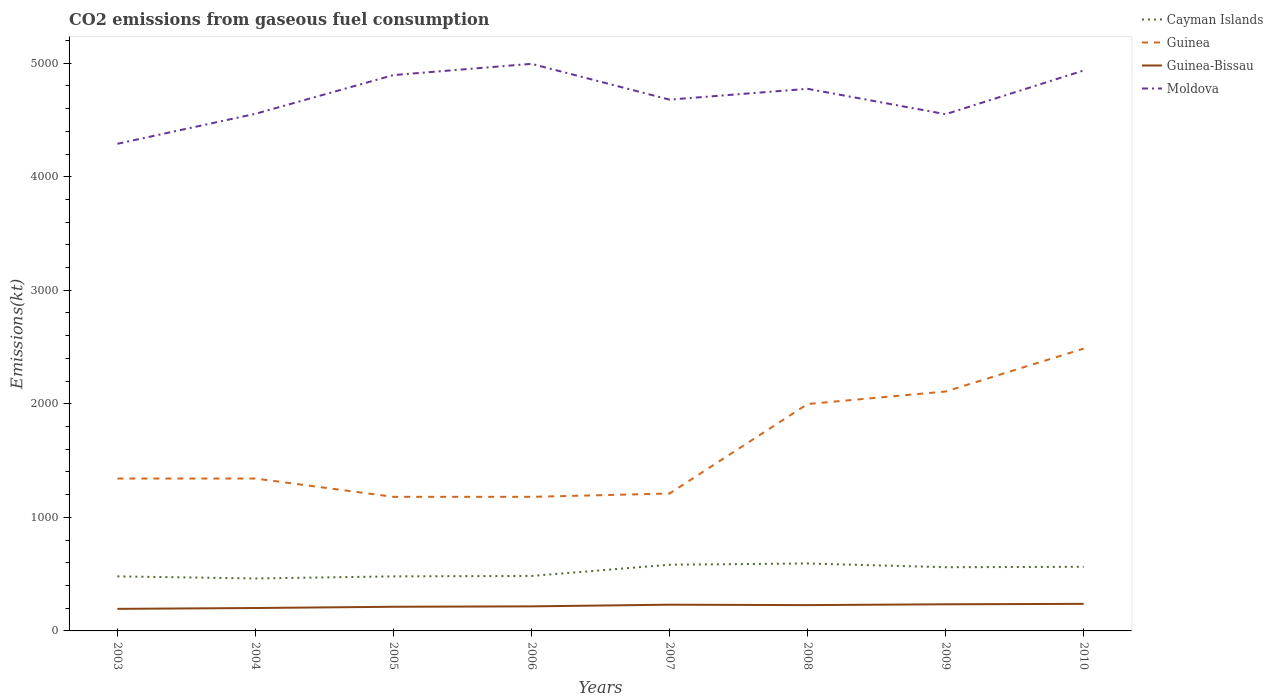How many different coloured lines are there?
Ensure brevity in your answer.  4. Is the number of lines equal to the number of legend labels?
Make the answer very short. Yes. Across all years, what is the maximum amount of CO2 emitted in Guinea-Bissau?
Offer a terse response. 194.35. In which year was the amount of CO2 emitted in Cayman Islands maximum?
Keep it short and to the point. 2004. What is the total amount of CO2 emitted in Moldova in the graph?
Offer a terse response. -484.04. What is the difference between the highest and the second highest amount of CO2 emitted in Guinea?
Your answer should be compact. 1305.45. What is the difference between the highest and the lowest amount of CO2 emitted in Cayman Islands?
Offer a terse response. 4. Is the amount of CO2 emitted in Guinea-Bissau strictly greater than the amount of CO2 emitted in Guinea over the years?
Your response must be concise. Yes. How many lines are there?
Offer a terse response. 4. What is the difference between two consecutive major ticks on the Y-axis?
Keep it short and to the point. 1000. Where does the legend appear in the graph?
Provide a short and direct response. Top right. What is the title of the graph?
Your response must be concise. CO2 emissions from gaseous fuel consumption. What is the label or title of the X-axis?
Your response must be concise. Years. What is the label or title of the Y-axis?
Your answer should be compact. Emissions(kt). What is the Emissions(kt) of Cayman Islands in 2003?
Your answer should be compact. 480.38. What is the Emissions(kt) in Guinea in 2003?
Keep it short and to the point. 1342.12. What is the Emissions(kt) in Guinea-Bissau in 2003?
Make the answer very short. 194.35. What is the Emissions(kt) of Moldova in 2003?
Your response must be concise. 4290.39. What is the Emissions(kt) of Cayman Islands in 2004?
Make the answer very short. 462.04. What is the Emissions(kt) of Guinea in 2004?
Offer a very short reply. 1342.12. What is the Emissions(kt) in Guinea-Bissau in 2004?
Make the answer very short. 201.69. What is the Emissions(kt) in Moldova in 2004?
Offer a terse response. 4554.41. What is the Emissions(kt) of Cayman Islands in 2005?
Make the answer very short. 480.38. What is the Emissions(kt) in Guinea in 2005?
Your answer should be compact. 1180.77. What is the Emissions(kt) of Guinea-Bissau in 2005?
Provide a succinct answer. 212.69. What is the Emissions(kt) in Moldova in 2005?
Provide a short and direct response. 4895.44. What is the Emissions(kt) in Cayman Islands in 2006?
Ensure brevity in your answer.  484.04. What is the Emissions(kt) in Guinea in 2006?
Your response must be concise. 1180.77. What is the Emissions(kt) of Guinea-Bissau in 2006?
Give a very brief answer. 216.35. What is the Emissions(kt) in Moldova in 2006?
Offer a terse response. 4994.45. What is the Emissions(kt) of Cayman Islands in 2007?
Offer a terse response. 583.05. What is the Emissions(kt) of Guinea in 2007?
Your answer should be compact. 1210.11. What is the Emissions(kt) of Guinea-Bissau in 2007?
Keep it short and to the point. 231.02. What is the Emissions(kt) of Moldova in 2007?
Give a very brief answer. 4679.09. What is the Emissions(kt) in Cayman Islands in 2008?
Keep it short and to the point. 594.05. What is the Emissions(kt) of Guinea in 2008?
Offer a terse response. 1998.52. What is the Emissions(kt) of Guinea-Bissau in 2008?
Your response must be concise. 227.35. What is the Emissions(kt) in Moldova in 2008?
Provide a succinct answer. 4774.43. What is the Emissions(kt) of Cayman Islands in 2009?
Provide a succinct answer. 561.05. What is the Emissions(kt) in Guinea in 2009?
Your response must be concise. 2108.53. What is the Emissions(kt) in Guinea-Bissau in 2009?
Keep it short and to the point. 234.69. What is the Emissions(kt) of Moldova in 2009?
Your response must be concise. 4550.75. What is the Emissions(kt) in Cayman Islands in 2010?
Give a very brief answer. 564.72. What is the Emissions(kt) of Guinea in 2010?
Provide a succinct answer. 2486.23. What is the Emissions(kt) in Guinea-Bissau in 2010?
Ensure brevity in your answer.  238.35. What is the Emissions(kt) in Moldova in 2010?
Ensure brevity in your answer.  4935.78. Across all years, what is the maximum Emissions(kt) of Cayman Islands?
Provide a succinct answer. 594.05. Across all years, what is the maximum Emissions(kt) in Guinea?
Provide a short and direct response. 2486.23. Across all years, what is the maximum Emissions(kt) of Guinea-Bissau?
Give a very brief answer. 238.35. Across all years, what is the maximum Emissions(kt) in Moldova?
Provide a succinct answer. 4994.45. Across all years, what is the minimum Emissions(kt) in Cayman Islands?
Keep it short and to the point. 462.04. Across all years, what is the minimum Emissions(kt) in Guinea?
Your answer should be very brief. 1180.77. Across all years, what is the minimum Emissions(kt) in Guinea-Bissau?
Your answer should be very brief. 194.35. Across all years, what is the minimum Emissions(kt) in Moldova?
Your response must be concise. 4290.39. What is the total Emissions(kt) in Cayman Islands in the graph?
Provide a succinct answer. 4209.72. What is the total Emissions(kt) in Guinea in the graph?
Offer a terse response. 1.28e+04. What is the total Emissions(kt) in Guinea-Bissau in the graph?
Offer a terse response. 1756.49. What is the total Emissions(kt) in Moldova in the graph?
Your answer should be very brief. 3.77e+04. What is the difference between the Emissions(kt) in Cayman Islands in 2003 and that in 2004?
Ensure brevity in your answer.  18.34. What is the difference between the Emissions(kt) of Guinea in 2003 and that in 2004?
Your response must be concise. 0. What is the difference between the Emissions(kt) of Guinea-Bissau in 2003 and that in 2004?
Keep it short and to the point. -7.33. What is the difference between the Emissions(kt) in Moldova in 2003 and that in 2004?
Your answer should be very brief. -264.02. What is the difference between the Emissions(kt) of Cayman Islands in 2003 and that in 2005?
Offer a terse response. 0. What is the difference between the Emissions(kt) of Guinea in 2003 and that in 2005?
Your response must be concise. 161.35. What is the difference between the Emissions(kt) in Guinea-Bissau in 2003 and that in 2005?
Provide a short and direct response. -18.34. What is the difference between the Emissions(kt) in Moldova in 2003 and that in 2005?
Make the answer very short. -605.05. What is the difference between the Emissions(kt) in Cayman Islands in 2003 and that in 2006?
Offer a terse response. -3.67. What is the difference between the Emissions(kt) of Guinea in 2003 and that in 2006?
Your answer should be compact. 161.35. What is the difference between the Emissions(kt) of Guinea-Bissau in 2003 and that in 2006?
Provide a succinct answer. -22. What is the difference between the Emissions(kt) in Moldova in 2003 and that in 2006?
Make the answer very short. -704.06. What is the difference between the Emissions(kt) of Cayman Islands in 2003 and that in 2007?
Offer a terse response. -102.68. What is the difference between the Emissions(kt) in Guinea in 2003 and that in 2007?
Provide a succinct answer. 132.01. What is the difference between the Emissions(kt) in Guinea-Bissau in 2003 and that in 2007?
Offer a very short reply. -36.67. What is the difference between the Emissions(kt) in Moldova in 2003 and that in 2007?
Provide a short and direct response. -388.7. What is the difference between the Emissions(kt) in Cayman Islands in 2003 and that in 2008?
Offer a terse response. -113.68. What is the difference between the Emissions(kt) in Guinea in 2003 and that in 2008?
Offer a very short reply. -656.39. What is the difference between the Emissions(kt) of Guinea-Bissau in 2003 and that in 2008?
Keep it short and to the point. -33. What is the difference between the Emissions(kt) of Moldova in 2003 and that in 2008?
Your response must be concise. -484.04. What is the difference between the Emissions(kt) of Cayman Islands in 2003 and that in 2009?
Offer a terse response. -80.67. What is the difference between the Emissions(kt) in Guinea in 2003 and that in 2009?
Offer a very short reply. -766.4. What is the difference between the Emissions(kt) in Guinea-Bissau in 2003 and that in 2009?
Provide a short and direct response. -40.34. What is the difference between the Emissions(kt) of Moldova in 2003 and that in 2009?
Your answer should be compact. -260.36. What is the difference between the Emissions(kt) of Cayman Islands in 2003 and that in 2010?
Your answer should be very brief. -84.34. What is the difference between the Emissions(kt) of Guinea in 2003 and that in 2010?
Your answer should be very brief. -1144.1. What is the difference between the Emissions(kt) in Guinea-Bissau in 2003 and that in 2010?
Offer a terse response. -44. What is the difference between the Emissions(kt) of Moldova in 2003 and that in 2010?
Provide a succinct answer. -645.39. What is the difference between the Emissions(kt) of Cayman Islands in 2004 and that in 2005?
Give a very brief answer. -18.34. What is the difference between the Emissions(kt) of Guinea in 2004 and that in 2005?
Make the answer very short. 161.35. What is the difference between the Emissions(kt) of Guinea-Bissau in 2004 and that in 2005?
Ensure brevity in your answer.  -11. What is the difference between the Emissions(kt) in Moldova in 2004 and that in 2005?
Provide a short and direct response. -341.03. What is the difference between the Emissions(kt) of Cayman Islands in 2004 and that in 2006?
Provide a short and direct response. -22. What is the difference between the Emissions(kt) of Guinea in 2004 and that in 2006?
Offer a very short reply. 161.35. What is the difference between the Emissions(kt) of Guinea-Bissau in 2004 and that in 2006?
Your answer should be very brief. -14.67. What is the difference between the Emissions(kt) in Moldova in 2004 and that in 2006?
Give a very brief answer. -440.04. What is the difference between the Emissions(kt) of Cayman Islands in 2004 and that in 2007?
Your response must be concise. -121.01. What is the difference between the Emissions(kt) of Guinea in 2004 and that in 2007?
Give a very brief answer. 132.01. What is the difference between the Emissions(kt) of Guinea-Bissau in 2004 and that in 2007?
Provide a succinct answer. -29.34. What is the difference between the Emissions(kt) in Moldova in 2004 and that in 2007?
Your answer should be very brief. -124.68. What is the difference between the Emissions(kt) of Cayman Islands in 2004 and that in 2008?
Provide a succinct answer. -132.01. What is the difference between the Emissions(kt) of Guinea in 2004 and that in 2008?
Make the answer very short. -656.39. What is the difference between the Emissions(kt) of Guinea-Bissau in 2004 and that in 2008?
Your answer should be very brief. -25.67. What is the difference between the Emissions(kt) of Moldova in 2004 and that in 2008?
Provide a succinct answer. -220.02. What is the difference between the Emissions(kt) of Cayman Islands in 2004 and that in 2009?
Provide a succinct answer. -99.01. What is the difference between the Emissions(kt) of Guinea in 2004 and that in 2009?
Keep it short and to the point. -766.4. What is the difference between the Emissions(kt) of Guinea-Bissau in 2004 and that in 2009?
Provide a succinct answer. -33. What is the difference between the Emissions(kt) of Moldova in 2004 and that in 2009?
Make the answer very short. 3.67. What is the difference between the Emissions(kt) of Cayman Islands in 2004 and that in 2010?
Provide a succinct answer. -102.68. What is the difference between the Emissions(kt) of Guinea in 2004 and that in 2010?
Provide a succinct answer. -1144.1. What is the difference between the Emissions(kt) in Guinea-Bissau in 2004 and that in 2010?
Offer a very short reply. -36.67. What is the difference between the Emissions(kt) in Moldova in 2004 and that in 2010?
Your answer should be very brief. -381.37. What is the difference between the Emissions(kt) in Cayman Islands in 2005 and that in 2006?
Offer a terse response. -3.67. What is the difference between the Emissions(kt) of Guinea in 2005 and that in 2006?
Offer a very short reply. 0. What is the difference between the Emissions(kt) of Guinea-Bissau in 2005 and that in 2006?
Keep it short and to the point. -3.67. What is the difference between the Emissions(kt) in Moldova in 2005 and that in 2006?
Your response must be concise. -99.01. What is the difference between the Emissions(kt) in Cayman Islands in 2005 and that in 2007?
Keep it short and to the point. -102.68. What is the difference between the Emissions(kt) of Guinea in 2005 and that in 2007?
Ensure brevity in your answer.  -29.34. What is the difference between the Emissions(kt) of Guinea-Bissau in 2005 and that in 2007?
Ensure brevity in your answer.  -18.34. What is the difference between the Emissions(kt) of Moldova in 2005 and that in 2007?
Offer a very short reply. 216.35. What is the difference between the Emissions(kt) in Cayman Islands in 2005 and that in 2008?
Offer a very short reply. -113.68. What is the difference between the Emissions(kt) of Guinea in 2005 and that in 2008?
Make the answer very short. -817.74. What is the difference between the Emissions(kt) of Guinea-Bissau in 2005 and that in 2008?
Your response must be concise. -14.67. What is the difference between the Emissions(kt) in Moldova in 2005 and that in 2008?
Provide a succinct answer. 121.01. What is the difference between the Emissions(kt) of Cayman Islands in 2005 and that in 2009?
Make the answer very short. -80.67. What is the difference between the Emissions(kt) of Guinea in 2005 and that in 2009?
Make the answer very short. -927.75. What is the difference between the Emissions(kt) in Guinea-Bissau in 2005 and that in 2009?
Ensure brevity in your answer.  -22. What is the difference between the Emissions(kt) of Moldova in 2005 and that in 2009?
Your answer should be very brief. 344.7. What is the difference between the Emissions(kt) in Cayman Islands in 2005 and that in 2010?
Your answer should be very brief. -84.34. What is the difference between the Emissions(kt) of Guinea in 2005 and that in 2010?
Offer a very short reply. -1305.45. What is the difference between the Emissions(kt) in Guinea-Bissau in 2005 and that in 2010?
Your response must be concise. -25.67. What is the difference between the Emissions(kt) in Moldova in 2005 and that in 2010?
Your answer should be compact. -40.34. What is the difference between the Emissions(kt) of Cayman Islands in 2006 and that in 2007?
Make the answer very short. -99.01. What is the difference between the Emissions(kt) of Guinea in 2006 and that in 2007?
Your answer should be compact. -29.34. What is the difference between the Emissions(kt) in Guinea-Bissau in 2006 and that in 2007?
Give a very brief answer. -14.67. What is the difference between the Emissions(kt) of Moldova in 2006 and that in 2007?
Offer a terse response. 315.36. What is the difference between the Emissions(kt) of Cayman Islands in 2006 and that in 2008?
Ensure brevity in your answer.  -110.01. What is the difference between the Emissions(kt) in Guinea in 2006 and that in 2008?
Your answer should be very brief. -817.74. What is the difference between the Emissions(kt) in Guinea-Bissau in 2006 and that in 2008?
Provide a succinct answer. -11. What is the difference between the Emissions(kt) of Moldova in 2006 and that in 2008?
Make the answer very short. 220.02. What is the difference between the Emissions(kt) in Cayman Islands in 2006 and that in 2009?
Your answer should be very brief. -77.01. What is the difference between the Emissions(kt) in Guinea in 2006 and that in 2009?
Give a very brief answer. -927.75. What is the difference between the Emissions(kt) of Guinea-Bissau in 2006 and that in 2009?
Make the answer very short. -18.34. What is the difference between the Emissions(kt) in Moldova in 2006 and that in 2009?
Make the answer very short. 443.71. What is the difference between the Emissions(kt) in Cayman Islands in 2006 and that in 2010?
Ensure brevity in your answer.  -80.67. What is the difference between the Emissions(kt) of Guinea in 2006 and that in 2010?
Offer a very short reply. -1305.45. What is the difference between the Emissions(kt) of Guinea-Bissau in 2006 and that in 2010?
Provide a succinct answer. -22. What is the difference between the Emissions(kt) in Moldova in 2006 and that in 2010?
Offer a terse response. 58.67. What is the difference between the Emissions(kt) of Cayman Islands in 2007 and that in 2008?
Keep it short and to the point. -11. What is the difference between the Emissions(kt) of Guinea in 2007 and that in 2008?
Offer a very short reply. -788.4. What is the difference between the Emissions(kt) of Guinea-Bissau in 2007 and that in 2008?
Your answer should be very brief. 3.67. What is the difference between the Emissions(kt) in Moldova in 2007 and that in 2008?
Your response must be concise. -95.34. What is the difference between the Emissions(kt) of Cayman Islands in 2007 and that in 2009?
Ensure brevity in your answer.  22. What is the difference between the Emissions(kt) of Guinea in 2007 and that in 2009?
Your answer should be compact. -898.41. What is the difference between the Emissions(kt) of Guinea-Bissau in 2007 and that in 2009?
Ensure brevity in your answer.  -3.67. What is the difference between the Emissions(kt) of Moldova in 2007 and that in 2009?
Offer a very short reply. 128.34. What is the difference between the Emissions(kt) in Cayman Islands in 2007 and that in 2010?
Ensure brevity in your answer.  18.34. What is the difference between the Emissions(kt) in Guinea in 2007 and that in 2010?
Your answer should be compact. -1276.12. What is the difference between the Emissions(kt) of Guinea-Bissau in 2007 and that in 2010?
Ensure brevity in your answer.  -7.33. What is the difference between the Emissions(kt) in Moldova in 2007 and that in 2010?
Offer a very short reply. -256.69. What is the difference between the Emissions(kt) in Cayman Islands in 2008 and that in 2009?
Your response must be concise. 33. What is the difference between the Emissions(kt) in Guinea in 2008 and that in 2009?
Ensure brevity in your answer.  -110.01. What is the difference between the Emissions(kt) in Guinea-Bissau in 2008 and that in 2009?
Make the answer very short. -7.33. What is the difference between the Emissions(kt) in Moldova in 2008 and that in 2009?
Ensure brevity in your answer.  223.69. What is the difference between the Emissions(kt) of Cayman Islands in 2008 and that in 2010?
Your answer should be compact. 29.34. What is the difference between the Emissions(kt) in Guinea in 2008 and that in 2010?
Your answer should be very brief. -487.71. What is the difference between the Emissions(kt) in Guinea-Bissau in 2008 and that in 2010?
Offer a terse response. -11. What is the difference between the Emissions(kt) of Moldova in 2008 and that in 2010?
Provide a short and direct response. -161.35. What is the difference between the Emissions(kt) of Cayman Islands in 2009 and that in 2010?
Make the answer very short. -3.67. What is the difference between the Emissions(kt) in Guinea in 2009 and that in 2010?
Offer a very short reply. -377.7. What is the difference between the Emissions(kt) of Guinea-Bissau in 2009 and that in 2010?
Offer a very short reply. -3.67. What is the difference between the Emissions(kt) in Moldova in 2009 and that in 2010?
Your answer should be compact. -385.04. What is the difference between the Emissions(kt) in Cayman Islands in 2003 and the Emissions(kt) in Guinea in 2004?
Provide a short and direct response. -861.75. What is the difference between the Emissions(kt) in Cayman Islands in 2003 and the Emissions(kt) in Guinea-Bissau in 2004?
Your answer should be compact. 278.69. What is the difference between the Emissions(kt) of Cayman Islands in 2003 and the Emissions(kt) of Moldova in 2004?
Provide a succinct answer. -4074.04. What is the difference between the Emissions(kt) of Guinea in 2003 and the Emissions(kt) of Guinea-Bissau in 2004?
Provide a succinct answer. 1140.44. What is the difference between the Emissions(kt) of Guinea in 2003 and the Emissions(kt) of Moldova in 2004?
Your answer should be very brief. -3212.29. What is the difference between the Emissions(kt) of Guinea-Bissau in 2003 and the Emissions(kt) of Moldova in 2004?
Offer a terse response. -4360.06. What is the difference between the Emissions(kt) of Cayman Islands in 2003 and the Emissions(kt) of Guinea in 2005?
Keep it short and to the point. -700.4. What is the difference between the Emissions(kt) of Cayman Islands in 2003 and the Emissions(kt) of Guinea-Bissau in 2005?
Keep it short and to the point. 267.69. What is the difference between the Emissions(kt) of Cayman Islands in 2003 and the Emissions(kt) of Moldova in 2005?
Offer a terse response. -4415.07. What is the difference between the Emissions(kt) in Guinea in 2003 and the Emissions(kt) in Guinea-Bissau in 2005?
Keep it short and to the point. 1129.44. What is the difference between the Emissions(kt) of Guinea in 2003 and the Emissions(kt) of Moldova in 2005?
Provide a succinct answer. -3553.32. What is the difference between the Emissions(kt) in Guinea-Bissau in 2003 and the Emissions(kt) in Moldova in 2005?
Keep it short and to the point. -4701.09. What is the difference between the Emissions(kt) in Cayman Islands in 2003 and the Emissions(kt) in Guinea in 2006?
Offer a terse response. -700.4. What is the difference between the Emissions(kt) of Cayman Islands in 2003 and the Emissions(kt) of Guinea-Bissau in 2006?
Your response must be concise. 264.02. What is the difference between the Emissions(kt) of Cayman Islands in 2003 and the Emissions(kt) of Moldova in 2006?
Offer a terse response. -4514.08. What is the difference between the Emissions(kt) in Guinea in 2003 and the Emissions(kt) in Guinea-Bissau in 2006?
Your answer should be compact. 1125.77. What is the difference between the Emissions(kt) in Guinea in 2003 and the Emissions(kt) in Moldova in 2006?
Keep it short and to the point. -3652.33. What is the difference between the Emissions(kt) of Guinea-Bissau in 2003 and the Emissions(kt) of Moldova in 2006?
Keep it short and to the point. -4800.1. What is the difference between the Emissions(kt) of Cayman Islands in 2003 and the Emissions(kt) of Guinea in 2007?
Offer a terse response. -729.73. What is the difference between the Emissions(kt) of Cayman Islands in 2003 and the Emissions(kt) of Guinea-Bissau in 2007?
Ensure brevity in your answer.  249.36. What is the difference between the Emissions(kt) of Cayman Islands in 2003 and the Emissions(kt) of Moldova in 2007?
Your response must be concise. -4198.72. What is the difference between the Emissions(kt) of Guinea in 2003 and the Emissions(kt) of Guinea-Bissau in 2007?
Ensure brevity in your answer.  1111.1. What is the difference between the Emissions(kt) of Guinea in 2003 and the Emissions(kt) of Moldova in 2007?
Provide a succinct answer. -3336.97. What is the difference between the Emissions(kt) of Guinea-Bissau in 2003 and the Emissions(kt) of Moldova in 2007?
Ensure brevity in your answer.  -4484.74. What is the difference between the Emissions(kt) in Cayman Islands in 2003 and the Emissions(kt) in Guinea in 2008?
Provide a short and direct response. -1518.14. What is the difference between the Emissions(kt) of Cayman Islands in 2003 and the Emissions(kt) of Guinea-Bissau in 2008?
Your response must be concise. 253.02. What is the difference between the Emissions(kt) of Cayman Islands in 2003 and the Emissions(kt) of Moldova in 2008?
Give a very brief answer. -4294.06. What is the difference between the Emissions(kt) of Guinea in 2003 and the Emissions(kt) of Guinea-Bissau in 2008?
Your response must be concise. 1114.77. What is the difference between the Emissions(kt) in Guinea in 2003 and the Emissions(kt) in Moldova in 2008?
Provide a short and direct response. -3432.31. What is the difference between the Emissions(kt) of Guinea-Bissau in 2003 and the Emissions(kt) of Moldova in 2008?
Your response must be concise. -4580.08. What is the difference between the Emissions(kt) in Cayman Islands in 2003 and the Emissions(kt) in Guinea in 2009?
Ensure brevity in your answer.  -1628.15. What is the difference between the Emissions(kt) in Cayman Islands in 2003 and the Emissions(kt) in Guinea-Bissau in 2009?
Provide a short and direct response. 245.69. What is the difference between the Emissions(kt) in Cayman Islands in 2003 and the Emissions(kt) in Moldova in 2009?
Provide a succinct answer. -4070.37. What is the difference between the Emissions(kt) in Guinea in 2003 and the Emissions(kt) in Guinea-Bissau in 2009?
Offer a terse response. 1107.43. What is the difference between the Emissions(kt) in Guinea in 2003 and the Emissions(kt) in Moldova in 2009?
Your answer should be compact. -3208.62. What is the difference between the Emissions(kt) of Guinea-Bissau in 2003 and the Emissions(kt) of Moldova in 2009?
Provide a short and direct response. -4356.4. What is the difference between the Emissions(kt) in Cayman Islands in 2003 and the Emissions(kt) in Guinea in 2010?
Your answer should be compact. -2005.85. What is the difference between the Emissions(kt) of Cayman Islands in 2003 and the Emissions(kt) of Guinea-Bissau in 2010?
Your answer should be compact. 242.02. What is the difference between the Emissions(kt) of Cayman Islands in 2003 and the Emissions(kt) of Moldova in 2010?
Your answer should be very brief. -4455.4. What is the difference between the Emissions(kt) in Guinea in 2003 and the Emissions(kt) in Guinea-Bissau in 2010?
Your answer should be compact. 1103.77. What is the difference between the Emissions(kt) in Guinea in 2003 and the Emissions(kt) in Moldova in 2010?
Make the answer very short. -3593.66. What is the difference between the Emissions(kt) of Guinea-Bissau in 2003 and the Emissions(kt) of Moldova in 2010?
Give a very brief answer. -4741.43. What is the difference between the Emissions(kt) in Cayman Islands in 2004 and the Emissions(kt) in Guinea in 2005?
Make the answer very short. -718.73. What is the difference between the Emissions(kt) of Cayman Islands in 2004 and the Emissions(kt) of Guinea-Bissau in 2005?
Ensure brevity in your answer.  249.36. What is the difference between the Emissions(kt) in Cayman Islands in 2004 and the Emissions(kt) in Moldova in 2005?
Ensure brevity in your answer.  -4433.4. What is the difference between the Emissions(kt) of Guinea in 2004 and the Emissions(kt) of Guinea-Bissau in 2005?
Your answer should be very brief. 1129.44. What is the difference between the Emissions(kt) of Guinea in 2004 and the Emissions(kt) of Moldova in 2005?
Your answer should be very brief. -3553.32. What is the difference between the Emissions(kt) of Guinea-Bissau in 2004 and the Emissions(kt) of Moldova in 2005?
Your answer should be very brief. -4693.76. What is the difference between the Emissions(kt) of Cayman Islands in 2004 and the Emissions(kt) of Guinea in 2006?
Your answer should be compact. -718.73. What is the difference between the Emissions(kt) in Cayman Islands in 2004 and the Emissions(kt) in Guinea-Bissau in 2006?
Offer a very short reply. 245.69. What is the difference between the Emissions(kt) in Cayman Islands in 2004 and the Emissions(kt) in Moldova in 2006?
Offer a terse response. -4532.41. What is the difference between the Emissions(kt) in Guinea in 2004 and the Emissions(kt) in Guinea-Bissau in 2006?
Provide a succinct answer. 1125.77. What is the difference between the Emissions(kt) in Guinea in 2004 and the Emissions(kt) in Moldova in 2006?
Your answer should be compact. -3652.33. What is the difference between the Emissions(kt) of Guinea-Bissau in 2004 and the Emissions(kt) of Moldova in 2006?
Offer a very short reply. -4792.77. What is the difference between the Emissions(kt) in Cayman Islands in 2004 and the Emissions(kt) in Guinea in 2007?
Your answer should be very brief. -748.07. What is the difference between the Emissions(kt) of Cayman Islands in 2004 and the Emissions(kt) of Guinea-Bissau in 2007?
Offer a very short reply. 231.02. What is the difference between the Emissions(kt) in Cayman Islands in 2004 and the Emissions(kt) in Moldova in 2007?
Your answer should be compact. -4217.05. What is the difference between the Emissions(kt) of Guinea in 2004 and the Emissions(kt) of Guinea-Bissau in 2007?
Your answer should be very brief. 1111.1. What is the difference between the Emissions(kt) in Guinea in 2004 and the Emissions(kt) in Moldova in 2007?
Ensure brevity in your answer.  -3336.97. What is the difference between the Emissions(kt) in Guinea-Bissau in 2004 and the Emissions(kt) in Moldova in 2007?
Make the answer very short. -4477.41. What is the difference between the Emissions(kt) of Cayman Islands in 2004 and the Emissions(kt) of Guinea in 2008?
Your answer should be very brief. -1536.47. What is the difference between the Emissions(kt) of Cayman Islands in 2004 and the Emissions(kt) of Guinea-Bissau in 2008?
Offer a terse response. 234.69. What is the difference between the Emissions(kt) in Cayman Islands in 2004 and the Emissions(kt) in Moldova in 2008?
Your response must be concise. -4312.39. What is the difference between the Emissions(kt) in Guinea in 2004 and the Emissions(kt) in Guinea-Bissau in 2008?
Ensure brevity in your answer.  1114.77. What is the difference between the Emissions(kt) of Guinea in 2004 and the Emissions(kt) of Moldova in 2008?
Provide a succinct answer. -3432.31. What is the difference between the Emissions(kt) in Guinea-Bissau in 2004 and the Emissions(kt) in Moldova in 2008?
Provide a short and direct response. -4572.75. What is the difference between the Emissions(kt) of Cayman Islands in 2004 and the Emissions(kt) of Guinea in 2009?
Offer a very short reply. -1646.48. What is the difference between the Emissions(kt) of Cayman Islands in 2004 and the Emissions(kt) of Guinea-Bissau in 2009?
Your answer should be compact. 227.35. What is the difference between the Emissions(kt) of Cayman Islands in 2004 and the Emissions(kt) of Moldova in 2009?
Provide a succinct answer. -4088.7. What is the difference between the Emissions(kt) in Guinea in 2004 and the Emissions(kt) in Guinea-Bissau in 2009?
Your response must be concise. 1107.43. What is the difference between the Emissions(kt) of Guinea in 2004 and the Emissions(kt) of Moldova in 2009?
Make the answer very short. -3208.62. What is the difference between the Emissions(kt) in Guinea-Bissau in 2004 and the Emissions(kt) in Moldova in 2009?
Offer a very short reply. -4349.06. What is the difference between the Emissions(kt) of Cayman Islands in 2004 and the Emissions(kt) of Guinea in 2010?
Ensure brevity in your answer.  -2024.18. What is the difference between the Emissions(kt) in Cayman Islands in 2004 and the Emissions(kt) in Guinea-Bissau in 2010?
Offer a very short reply. 223.69. What is the difference between the Emissions(kt) in Cayman Islands in 2004 and the Emissions(kt) in Moldova in 2010?
Keep it short and to the point. -4473.74. What is the difference between the Emissions(kt) of Guinea in 2004 and the Emissions(kt) of Guinea-Bissau in 2010?
Offer a very short reply. 1103.77. What is the difference between the Emissions(kt) of Guinea in 2004 and the Emissions(kt) of Moldova in 2010?
Your answer should be compact. -3593.66. What is the difference between the Emissions(kt) in Guinea-Bissau in 2004 and the Emissions(kt) in Moldova in 2010?
Give a very brief answer. -4734.1. What is the difference between the Emissions(kt) of Cayman Islands in 2005 and the Emissions(kt) of Guinea in 2006?
Keep it short and to the point. -700.4. What is the difference between the Emissions(kt) in Cayman Islands in 2005 and the Emissions(kt) in Guinea-Bissau in 2006?
Your response must be concise. 264.02. What is the difference between the Emissions(kt) in Cayman Islands in 2005 and the Emissions(kt) in Moldova in 2006?
Make the answer very short. -4514.08. What is the difference between the Emissions(kt) in Guinea in 2005 and the Emissions(kt) in Guinea-Bissau in 2006?
Provide a short and direct response. 964.42. What is the difference between the Emissions(kt) in Guinea in 2005 and the Emissions(kt) in Moldova in 2006?
Ensure brevity in your answer.  -3813.68. What is the difference between the Emissions(kt) of Guinea-Bissau in 2005 and the Emissions(kt) of Moldova in 2006?
Offer a very short reply. -4781.77. What is the difference between the Emissions(kt) in Cayman Islands in 2005 and the Emissions(kt) in Guinea in 2007?
Keep it short and to the point. -729.73. What is the difference between the Emissions(kt) in Cayman Islands in 2005 and the Emissions(kt) in Guinea-Bissau in 2007?
Offer a very short reply. 249.36. What is the difference between the Emissions(kt) in Cayman Islands in 2005 and the Emissions(kt) in Moldova in 2007?
Make the answer very short. -4198.72. What is the difference between the Emissions(kt) of Guinea in 2005 and the Emissions(kt) of Guinea-Bissau in 2007?
Your answer should be very brief. 949.75. What is the difference between the Emissions(kt) of Guinea in 2005 and the Emissions(kt) of Moldova in 2007?
Make the answer very short. -3498.32. What is the difference between the Emissions(kt) of Guinea-Bissau in 2005 and the Emissions(kt) of Moldova in 2007?
Give a very brief answer. -4466.41. What is the difference between the Emissions(kt) of Cayman Islands in 2005 and the Emissions(kt) of Guinea in 2008?
Ensure brevity in your answer.  -1518.14. What is the difference between the Emissions(kt) in Cayman Islands in 2005 and the Emissions(kt) in Guinea-Bissau in 2008?
Your answer should be very brief. 253.02. What is the difference between the Emissions(kt) of Cayman Islands in 2005 and the Emissions(kt) of Moldova in 2008?
Give a very brief answer. -4294.06. What is the difference between the Emissions(kt) in Guinea in 2005 and the Emissions(kt) in Guinea-Bissau in 2008?
Give a very brief answer. 953.42. What is the difference between the Emissions(kt) in Guinea in 2005 and the Emissions(kt) in Moldova in 2008?
Make the answer very short. -3593.66. What is the difference between the Emissions(kt) of Guinea-Bissau in 2005 and the Emissions(kt) of Moldova in 2008?
Offer a very short reply. -4561.75. What is the difference between the Emissions(kt) of Cayman Islands in 2005 and the Emissions(kt) of Guinea in 2009?
Make the answer very short. -1628.15. What is the difference between the Emissions(kt) in Cayman Islands in 2005 and the Emissions(kt) in Guinea-Bissau in 2009?
Provide a succinct answer. 245.69. What is the difference between the Emissions(kt) of Cayman Islands in 2005 and the Emissions(kt) of Moldova in 2009?
Offer a very short reply. -4070.37. What is the difference between the Emissions(kt) of Guinea in 2005 and the Emissions(kt) of Guinea-Bissau in 2009?
Provide a succinct answer. 946.09. What is the difference between the Emissions(kt) in Guinea in 2005 and the Emissions(kt) in Moldova in 2009?
Make the answer very short. -3369.97. What is the difference between the Emissions(kt) of Guinea-Bissau in 2005 and the Emissions(kt) of Moldova in 2009?
Your response must be concise. -4338.06. What is the difference between the Emissions(kt) of Cayman Islands in 2005 and the Emissions(kt) of Guinea in 2010?
Your answer should be very brief. -2005.85. What is the difference between the Emissions(kt) in Cayman Islands in 2005 and the Emissions(kt) in Guinea-Bissau in 2010?
Your response must be concise. 242.02. What is the difference between the Emissions(kt) in Cayman Islands in 2005 and the Emissions(kt) in Moldova in 2010?
Make the answer very short. -4455.4. What is the difference between the Emissions(kt) of Guinea in 2005 and the Emissions(kt) of Guinea-Bissau in 2010?
Your answer should be very brief. 942.42. What is the difference between the Emissions(kt) in Guinea in 2005 and the Emissions(kt) in Moldova in 2010?
Your answer should be very brief. -3755.01. What is the difference between the Emissions(kt) of Guinea-Bissau in 2005 and the Emissions(kt) of Moldova in 2010?
Provide a short and direct response. -4723.1. What is the difference between the Emissions(kt) of Cayman Islands in 2006 and the Emissions(kt) of Guinea in 2007?
Offer a terse response. -726.07. What is the difference between the Emissions(kt) in Cayman Islands in 2006 and the Emissions(kt) in Guinea-Bissau in 2007?
Make the answer very short. 253.02. What is the difference between the Emissions(kt) in Cayman Islands in 2006 and the Emissions(kt) in Moldova in 2007?
Ensure brevity in your answer.  -4195.05. What is the difference between the Emissions(kt) of Guinea in 2006 and the Emissions(kt) of Guinea-Bissau in 2007?
Your response must be concise. 949.75. What is the difference between the Emissions(kt) in Guinea in 2006 and the Emissions(kt) in Moldova in 2007?
Provide a short and direct response. -3498.32. What is the difference between the Emissions(kt) in Guinea-Bissau in 2006 and the Emissions(kt) in Moldova in 2007?
Your answer should be compact. -4462.74. What is the difference between the Emissions(kt) of Cayman Islands in 2006 and the Emissions(kt) of Guinea in 2008?
Give a very brief answer. -1514.47. What is the difference between the Emissions(kt) in Cayman Islands in 2006 and the Emissions(kt) in Guinea-Bissau in 2008?
Provide a short and direct response. 256.69. What is the difference between the Emissions(kt) of Cayman Islands in 2006 and the Emissions(kt) of Moldova in 2008?
Offer a terse response. -4290.39. What is the difference between the Emissions(kt) of Guinea in 2006 and the Emissions(kt) of Guinea-Bissau in 2008?
Your response must be concise. 953.42. What is the difference between the Emissions(kt) of Guinea in 2006 and the Emissions(kt) of Moldova in 2008?
Your answer should be compact. -3593.66. What is the difference between the Emissions(kt) of Guinea-Bissau in 2006 and the Emissions(kt) of Moldova in 2008?
Offer a terse response. -4558.08. What is the difference between the Emissions(kt) in Cayman Islands in 2006 and the Emissions(kt) in Guinea in 2009?
Provide a succinct answer. -1624.48. What is the difference between the Emissions(kt) of Cayman Islands in 2006 and the Emissions(kt) of Guinea-Bissau in 2009?
Ensure brevity in your answer.  249.36. What is the difference between the Emissions(kt) in Cayman Islands in 2006 and the Emissions(kt) in Moldova in 2009?
Your answer should be compact. -4066.7. What is the difference between the Emissions(kt) in Guinea in 2006 and the Emissions(kt) in Guinea-Bissau in 2009?
Offer a terse response. 946.09. What is the difference between the Emissions(kt) of Guinea in 2006 and the Emissions(kt) of Moldova in 2009?
Provide a succinct answer. -3369.97. What is the difference between the Emissions(kt) in Guinea-Bissau in 2006 and the Emissions(kt) in Moldova in 2009?
Give a very brief answer. -4334.39. What is the difference between the Emissions(kt) in Cayman Islands in 2006 and the Emissions(kt) in Guinea in 2010?
Offer a terse response. -2002.18. What is the difference between the Emissions(kt) of Cayman Islands in 2006 and the Emissions(kt) of Guinea-Bissau in 2010?
Make the answer very short. 245.69. What is the difference between the Emissions(kt) in Cayman Islands in 2006 and the Emissions(kt) in Moldova in 2010?
Your answer should be compact. -4451.74. What is the difference between the Emissions(kt) in Guinea in 2006 and the Emissions(kt) in Guinea-Bissau in 2010?
Offer a terse response. 942.42. What is the difference between the Emissions(kt) in Guinea in 2006 and the Emissions(kt) in Moldova in 2010?
Your response must be concise. -3755.01. What is the difference between the Emissions(kt) of Guinea-Bissau in 2006 and the Emissions(kt) of Moldova in 2010?
Keep it short and to the point. -4719.43. What is the difference between the Emissions(kt) in Cayman Islands in 2007 and the Emissions(kt) in Guinea in 2008?
Provide a short and direct response. -1415.46. What is the difference between the Emissions(kt) of Cayman Islands in 2007 and the Emissions(kt) of Guinea-Bissau in 2008?
Keep it short and to the point. 355.7. What is the difference between the Emissions(kt) in Cayman Islands in 2007 and the Emissions(kt) in Moldova in 2008?
Your answer should be compact. -4191.38. What is the difference between the Emissions(kt) of Guinea in 2007 and the Emissions(kt) of Guinea-Bissau in 2008?
Your answer should be very brief. 982.76. What is the difference between the Emissions(kt) in Guinea in 2007 and the Emissions(kt) in Moldova in 2008?
Your answer should be very brief. -3564.32. What is the difference between the Emissions(kt) of Guinea-Bissau in 2007 and the Emissions(kt) of Moldova in 2008?
Keep it short and to the point. -4543.41. What is the difference between the Emissions(kt) in Cayman Islands in 2007 and the Emissions(kt) in Guinea in 2009?
Provide a succinct answer. -1525.47. What is the difference between the Emissions(kt) in Cayman Islands in 2007 and the Emissions(kt) in Guinea-Bissau in 2009?
Make the answer very short. 348.37. What is the difference between the Emissions(kt) in Cayman Islands in 2007 and the Emissions(kt) in Moldova in 2009?
Provide a succinct answer. -3967.69. What is the difference between the Emissions(kt) of Guinea in 2007 and the Emissions(kt) of Guinea-Bissau in 2009?
Make the answer very short. 975.42. What is the difference between the Emissions(kt) in Guinea in 2007 and the Emissions(kt) in Moldova in 2009?
Offer a very short reply. -3340.64. What is the difference between the Emissions(kt) of Guinea-Bissau in 2007 and the Emissions(kt) of Moldova in 2009?
Keep it short and to the point. -4319.73. What is the difference between the Emissions(kt) of Cayman Islands in 2007 and the Emissions(kt) of Guinea in 2010?
Keep it short and to the point. -1903.17. What is the difference between the Emissions(kt) in Cayman Islands in 2007 and the Emissions(kt) in Guinea-Bissau in 2010?
Keep it short and to the point. 344.7. What is the difference between the Emissions(kt) in Cayman Islands in 2007 and the Emissions(kt) in Moldova in 2010?
Your answer should be compact. -4352.73. What is the difference between the Emissions(kt) in Guinea in 2007 and the Emissions(kt) in Guinea-Bissau in 2010?
Ensure brevity in your answer.  971.75. What is the difference between the Emissions(kt) in Guinea in 2007 and the Emissions(kt) in Moldova in 2010?
Make the answer very short. -3725.67. What is the difference between the Emissions(kt) of Guinea-Bissau in 2007 and the Emissions(kt) of Moldova in 2010?
Offer a terse response. -4704.76. What is the difference between the Emissions(kt) in Cayman Islands in 2008 and the Emissions(kt) in Guinea in 2009?
Your answer should be very brief. -1514.47. What is the difference between the Emissions(kt) in Cayman Islands in 2008 and the Emissions(kt) in Guinea-Bissau in 2009?
Make the answer very short. 359.37. What is the difference between the Emissions(kt) of Cayman Islands in 2008 and the Emissions(kt) of Moldova in 2009?
Provide a short and direct response. -3956.69. What is the difference between the Emissions(kt) of Guinea in 2008 and the Emissions(kt) of Guinea-Bissau in 2009?
Your answer should be compact. 1763.83. What is the difference between the Emissions(kt) in Guinea in 2008 and the Emissions(kt) in Moldova in 2009?
Make the answer very short. -2552.23. What is the difference between the Emissions(kt) in Guinea-Bissau in 2008 and the Emissions(kt) in Moldova in 2009?
Keep it short and to the point. -4323.39. What is the difference between the Emissions(kt) in Cayman Islands in 2008 and the Emissions(kt) in Guinea in 2010?
Provide a short and direct response. -1892.17. What is the difference between the Emissions(kt) of Cayman Islands in 2008 and the Emissions(kt) of Guinea-Bissau in 2010?
Give a very brief answer. 355.7. What is the difference between the Emissions(kt) in Cayman Islands in 2008 and the Emissions(kt) in Moldova in 2010?
Keep it short and to the point. -4341.73. What is the difference between the Emissions(kt) of Guinea in 2008 and the Emissions(kt) of Guinea-Bissau in 2010?
Make the answer very short. 1760.16. What is the difference between the Emissions(kt) in Guinea in 2008 and the Emissions(kt) in Moldova in 2010?
Offer a terse response. -2937.27. What is the difference between the Emissions(kt) in Guinea-Bissau in 2008 and the Emissions(kt) in Moldova in 2010?
Offer a terse response. -4708.43. What is the difference between the Emissions(kt) in Cayman Islands in 2009 and the Emissions(kt) in Guinea in 2010?
Your answer should be very brief. -1925.17. What is the difference between the Emissions(kt) of Cayman Islands in 2009 and the Emissions(kt) of Guinea-Bissau in 2010?
Offer a terse response. 322.7. What is the difference between the Emissions(kt) of Cayman Islands in 2009 and the Emissions(kt) of Moldova in 2010?
Give a very brief answer. -4374.73. What is the difference between the Emissions(kt) of Guinea in 2009 and the Emissions(kt) of Guinea-Bissau in 2010?
Make the answer very short. 1870.17. What is the difference between the Emissions(kt) in Guinea in 2009 and the Emissions(kt) in Moldova in 2010?
Provide a short and direct response. -2827.26. What is the difference between the Emissions(kt) in Guinea-Bissau in 2009 and the Emissions(kt) in Moldova in 2010?
Provide a short and direct response. -4701.09. What is the average Emissions(kt) in Cayman Islands per year?
Ensure brevity in your answer.  526.21. What is the average Emissions(kt) in Guinea per year?
Offer a terse response. 1606.15. What is the average Emissions(kt) of Guinea-Bissau per year?
Your response must be concise. 219.56. What is the average Emissions(kt) in Moldova per year?
Ensure brevity in your answer.  4709.34. In the year 2003, what is the difference between the Emissions(kt) of Cayman Islands and Emissions(kt) of Guinea?
Keep it short and to the point. -861.75. In the year 2003, what is the difference between the Emissions(kt) of Cayman Islands and Emissions(kt) of Guinea-Bissau?
Ensure brevity in your answer.  286.03. In the year 2003, what is the difference between the Emissions(kt) of Cayman Islands and Emissions(kt) of Moldova?
Your response must be concise. -3810.01. In the year 2003, what is the difference between the Emissions(kt) in Guinea and Emissions(kt) in Guinea-Bissau?
Keep it short and to the point. 1147.77. In the year 2003, what is the difference between the Emissions(kt) of Guinea and Emissions(kt) of Moldova?
Your answer should be very brief. -2948.27. In the year 2003, what is the difference between the Emissions(kt) in Guinea-Bissau and Emissions(kt) in Moldova?
Offer a very short reply. -4096.04. In the year 2004, what is the difference between the Emissions(kt) of Cayman Islands and Emissions(kt) of Guinea?
Keep it short and to the point. -880.08. In the year 2004, what is the difference between the Emissions(kt) in Cayman Islands and Emissions(kt) in Guinea-Bissau?
Give a very brief answer. 260.36. In the year 2004, what is the difference between the Emissions(kt) of Cayman Islands and Emissions(kt) of Moldova?
Your response must be concise. -4092.37. In the year 2004, what is the difference between the Emissions(kt) in Guinea and Emissions(kt) in Guinea-Bissau?
Offer a very short reply. 1140.44. In the year 2004, what is the difference between the Emissions(kt) of Guinea and Emissions(kt) of Moldova?
Provide a short and direct response. -3212.29. In the year 2004, what is the difference between the Emissions(kt) of Guinea-Bissau and Emissions(kt) of Moldova?
Your response must be concise. -4352.73. In the year 2005, what is the difference between the Emissions(kt) in Cayman Islands and Emissions(kt) in Guinea?
Keep it short and to the point. -700.4. In the year 2005, what is the difference between the Emissions(kt) in Cayman Islands and Emissions(kt) in Guinea-Bissau?
Your answer should be compact. 267.69. In the year 2005, what is the difference between the Emissions(kt) in Cayman Islands and Emissions(kt) in Moldova?
Provide a short and direct response. -4415.07. In the year 2005, what is the difference between the Emissions(kt) in Guinea and Emissions(kt) in Guinea-Bissau?
Provide a short and direct response. 968.09. In the year 2005, what is the difference between the Emissions(kt) in Guinea and Emissions(kt) in Moldova?
Give a very brief answer. -3714.67. In the year 2005, what is the difference between the Emissions(kt) of Guinea-Bissau and Emissions(kt) of Moldova?
Offer a very short reply. -4682.76. In the year 2006, what is the difference between the Emissions(kt) of Cayman Islands and Emissions(kt) of Guinea?
Keep it short and to the point. -696.73. In the year 2006, what is the difference between the Emissions(kt) of Cayman Islands and Emissions(kt) of Guinea-Bissau?
Make the answer very short. 267.69. In the year 2006, what is the difference between the Emissions(kt) of Cayman Islands and Emissions(kt) of Moldova?
Give a very brief answer. -4510.41. In the year 2006, what is the difference between the Emissions(kt) in Guinea and Emissions(kt) in Guinea-Bissau?
Provide a succinct answer. 964.42. In the year 2006, what is the difference between the Emissions(kt) of Guinea and Emissions(kt) of Moldova?
Provide a succinct answer. -3813.68. In the year 2006, what is the difference between the Emissions(kt) in Guinea-Bissau and Emissions(kt) in Moldova?
Your response must be concise. -4778.1. In the year 2007, what is the difference between the Emissions(kt) in Cayman Islands and Emissions(kt) in Guinea?
Offer a very short reply. -627.06. In the year 2007, what is the difference between the Emissions(kt) of Cayman Islands and Emissions(kt) of Guinea-Bissau?
Ensure brevity in your answer.  352.03. In the year 2007, what is the difference between the Emissions(kt) in Cayman Islands and Emissions(kt) in Moldova?
Give a very brief answer. -4096.04. In the year 2007, what is the difference between the Emissions(kt) of Guinea and Emissions(kt) of Guinea-Bissau?
Make the answer very short. 979.09. In the year 2007, what is the difference between the Emissions(kt) of Guinea and Emissions(kt) of Moldova?
Give a very brief answer. -3468.98. In the year 2007, what is the difference between the Emissions(kt) of Guinea-Bissau and Emissions(kt) of Moldova?
Provide a succinct answer. -4448.07. In the year 2008, what is the difference between the Emissions(kt) in Cayman Islands and Emissions(kt) in Guinea?
Provide a succinct answer. -1404.46. In the year 2008, what is the difference between the Emissions(kt) in Cayman Islands and Emissions(kt) in Guinea-Bissau?
Provide a succinct answer. 366.7. In the year 2008, what is the difference between the Emissions(kt) of Cayman Islands and Emissions(kt) of Moldova?
Your response must be concise. -4180.38. In the year 2008, what is the difference between the Emissions(kt) in Guinea and Emissions(kt) in Guinea-Bissau?
Ensure brevity in your answer.  1771.16. In the year 2008, what is the difference between the Emissions(kt) in Guinea and Emissions(kt) in Moldova?
Give a very brief answer. -2775.92. In the year 2008, what is the difference between the Emissions(kt) of Guinea-Bissau and Emissions(kt) of Moldova?
Your response must be concise. -4547.08. In the year 2009, what is the difference between the Emissions(kt) in Cayman Islands and Emissions(kt) in Guinea?
Keep it short and to the point. -1547.47. In the year 2009, what is the difference between the Emissions(kt) of Cayman Islands and Emissions(kt) of Guinea-Bissau?
Provide a short and direct response. 326.36. In the year 2009, what is the difference between the Emissions(kt) in Cayman Islands and Emissions(kt) in Moldova?
Make the answer very short. -3989.7. In the year 2009, what is the difference between the Emissions(kt) in Guinea and Emissions(kt) in Guinea-Bissau?
Keep it short and to the point. 1873.84. In the year 2009, what is the difference between the Emissions(kt) of Guinea and Emissions(kt) of Moldova?
Your answer should be very brief. -2442.22. In the year 2009, what is the difference between the Emissions(kt) of Guinea-Bissau and Emissions(kt) of Moldova?
Offer a terse response. -4316.06. In the year 2010, what is the difference between the Emissions(kt) of Cayman Islands and Emissions(kt) of Guinea?
Your answer should be compact. -1921.51. In the year 2010, what is the difference between the Emissions(kt) of Cayman Islands and Emissions(kt) of Guinea-Bissau?
Ensure brevity in your answer.  326.36. In the year 2010, what is the difference between the Emissions(kt) in Cayman Islands and Emissions(kt) in Moldova?
Give a very brief answer. -4371.06. In the year 2010, what is the difference between the Emissions(kt) in Guinea and Emissions(kt) in Guinea-Bissau?
Provide a short and direct response. 2247.87. In the year 2010, what is the difference between the Emissions(kt) of Guinea and Emissions(kt) of Moldova?
Your answer should be compact. -2449.56. In the year 2010, what is the difference between the Emissions(kt) of Guinea-Bissau and Emissions(kt) of Moldova?
Your response must be concise. -4697.43. What is the ratio of the Emissions(kt) in Cayman Islands in 2003 to that in 2004?
Your response must be concise. 1.04. What is the ratio of the Emissions(kt) of Guinea-Bissau in 2003 to that in 2004?
Make the answer very short. 0.96. What is the ratio of the Emissions(kt) in Moldova in 2003 to that in 2004?
Offer a terse response. 0.94. What is the ratio of the Emissions(kt) of Guinea in 2003 to that in 2005?
Offer a terse response. 1.14. What is the ratio of the Emissions(kt) in Guinea-Bissau in 2003 to that in 2005?
Your answer should be very brief. 0.91. What is the ratio of the Emissions(kt) of Moldova in 2003 to that in 2005?
Offer a terse response. 0.88. What is the ratio of the Emissions(kt) in Cayman Islands in 2003 to that in 2006?
Ensure brevity in your answer.  0.99. What is the ratio of the Emissions(kt) in Guinea in 2003 to that in 2006?
Provide a succinct answer. 1.14. What is the ratio of the Emissions(kt) in Guinea-Bissau in 2003 to that in 2006?
Your response must be concise. 0.9. What is the ratio of the Emissions(kt) of Moldova in 2003 to that in 2006?
Offer a very short reply. 0.86. What is the ratio of the Emissions(kt) of Cayman Islands in 2003 to that in 2007?
Ensure brevity in your answer.  0.82. What is the ratio of the Emissions(kt) in Guinea in 2003 to that in 2007?
Your response must be concise. 1.11. What is the ratio of the Emissions(kt) of Guinea-Bissau in 2003 to that in 2007?
Make the answer very short. 0.84. What is the ratio of the Emissions(kt) of Moldova in 2003 to that in 2007?
Offer a very short reply. 0.92. What is the ratio of the Emissions(kt) in Cayman Islands in 2003 to that in 2008?
Offer a terse response. 0.81. What is the ratio of the Emissions(kt) in Guinea in 2003 to that in 2008?
Ensure brevity in your answer.  0.67. What is the ratio of the Emissions(kt) of Guinea-Bissau in 2003 to that in 2008?
Your answer should be very brief. 0.85. What is the ratio of the Emissions(kt) of Moldova in 2003 to that in 2008?
Give a very brief answer. 0.9. What is the ratio of the Emissions(kt) in Cayman Islands in 2003 to that in 2009?
Offer a very short reply. 0.86. What is the ratio of the Emissions(kt) in Guinea in 2003 to that in 2009?
Make the answer very short. 0.64. What is the ratio of the Emissions(kt) in Guinea-Bissau in 2003 to that in 2009?
Provide a short and direct response. 0.83. What is the ratio of the Emissions(kt) in Moldova in 2003 to that in 2009?
Offer a terse response. 0.94. What is the ratio of the Emissions(kt) of Cayman Islands in 2003 to that in 2010?
Your response must be concise. 0.85. What is the ratio of the Emissions(kt) of Guinea in 2003 to that in 2010?
Ensure brevity in your answer.  0.54. What is the ratio of the Emissions(kt) of Guinea-Bissau in 2003 to that in 2010?
Provide a short and direct response. 0.82. What is the ratio of the Emissions(kt) of Moldova in 2003 to that in 2010?
Ensure brevity in your answer.  0.87. What is the ratio of the Emissions(kt) of Cayman Islands in 2004 to that in 2005?
Your answer should be very brief. 0.96. What is the ratio of the Emissions(kt) of Guinea in 2004 to that in 2005?
Your answer should be very brief. 1.14. What is the ratio of the Emissions(kt) in Guinea-Bissau in 2004 to that in 2005?
Offer a terse response. 0.95. What is the ratio of the Emissions(kt) in Moldova in 2004 to that in 2005?
Give a very brief answer. 0.93. What is the ratio of the Emissions(kt) in Cayman Islands in 2004 to that in 2006?
Keep it short and to the point. 0.95. What is the ratio of the Emissions(kt) in Guinea in 2004 to that in 2006?
Keep it short and to the point. 1.14. What is the ratio of the Emissions(kt) in Guinea-Bissau in 2004 to that in 2006?
Your answer should be compact. 0.93. What is the ratio of the Emissions(kt) in Moldova in 2004 to that in 2006?
Offer a very short reply. 0.91. What is the ratio of the Emissions(kt) in Cayman Islands in 2004 to that in 2007?
Offer a terse response. 0.79. What is the ratio of the Emissions(kt) of Guinea in 2004 to that in 2007?
Offer a terse response. 1.11. What is the ratio of the Emissions(kt) in Guinea-Bissau in 2004 to that in 2007?
Offer a terse response. 0.87. What is the ratio of the Emissions(kt) in Moldova in 2004 to that in 2007?
Provide a short and direct response. 0.97. What is the ratio of the Emissions(kt) of Cayman Islands in 2004 to that in 2008?
Make the answer very short. 0.78. What is the ratio of the Emissions(kt) in Guinea in 2004 to that in 2008?
Your answer should be very brief. 0.67. What is the ratio of the Emissions(kt) of Guinea-Bissau in 2004 to that in 2008?
Keep it short and to the point. 0.89. What is the ratio of the Emissions(kt) in Moldova in 2004 to that in 2008?
Make the answer very short. 0.95. What is the ratio of the Emissions(kt) in Cayman Islands in 2004 to that in 2009?
Keep it short and to the point. 0.82. What is the ratio of the Emissions(kt) in Guinea in 2004 to that in 2009?
Your answer should be very brief. 0.64. What is the ratio of the Emissions(kt) in Guinea-Bissau in 2004 to that in 2009?
Offer a very short reply. 0.86. What is the ratio of the Emissions(kt) in Moldova in 2004 to that in 2009?
Provide a short and direct response. 1. What is the ratio of the Emissions(kt) of Cayman Islands in 2004 to that in 2010?
Your answer should be compact. 0.82. What is the ratio of the Emissions(kt) of Guinea in 2004 to that in 2010?
Provide a short and direct response. 0.54. What is the ratio of the Emissions(kt) of Guinea-Bissau in 2004 to that in 2010?
Your response must be concise. 0.85. What is the ratio of the Emissions(kt) in Moldova in 2004 to that in 2010?
Your answer should be compact. 0.92. What is the ratio of the Emissions(kt) in Cayman Islands in 2005 to that in 2006?
Offer a very short reply. 0.99. What is the ratio of the Emissions(kt) of Guinea in 2005 to that in 2006?
Provide a succinct answer. 1. What is the ratio of the Emissions(kt) in Guinea-Bissau in 2005 to that in 2006?
Your response must be concise. 0.98. What is the ratio of the Emissions(kt) of Moldova in 2005 to that in 2006?
Provide a succinct answer. 0.98. What is the ratio of the Emissions(kt) in Cayman Islands in 2005 to that in 2007?
Give a very brief answer. 0.82. What is the ratio of the Emissions(kt) of Guinea in 2005 to that in 2007?
Offer a very short reply. 0.98. What is the ratio of the Emissions(kt) in Guinea-Bissau in 2005 to that in 2007?
Your answer should be very brief. 0.92. What is the ratio of the Emissions(kt) in Moldova in 2005 to that in 2007?
Offer a terse response. 1.05. What is the ratio of the Emissions(kt) of Cayman Islands in 2005 to that in 2008?
Provide a succinct answer. 0.81. What is the ratio of the Emissions(kt) of Guinea in 2005 to that in 2008?
Make the answer very short. 0.59. What is the ratio of the Emissions(kt) of Guinea-Bissau in 2005 to that in 2008?
Provide a short and direct response. 0.94. What is the ratio of the Emissions(kt) in Moldova in 2005 to that in 2008?
Give a very brief answer. 1.03. What is the ratio of the Emissions(kt) of Cayman Islands in 2005 to that in 2009?
Offer a terse response. 0.86. What is the ratio of the Emissions(kt) of Guinea in 2005 to that in 2009?
Your answer should be very brief. 0.56. What is the ratio of the Emissions(kt) in Guinea-Bissau in 2005 to that in 2009?
Offer a very short reply. 0.91. What is the ratio of the Emissions(kt) in Moldova in 2005 to that in 2009?
Keep it short and to the point. 1.08. What is the ratio of the Emissions(kt) of Cayman Islands in 2005 to that in 2010?
Provide a short and direct response. 0.85. What is the ratio of the Emissions(kt) of Guinea in 2005 to that in 2010?
Offer a terse response. 0.47. What is the ratio of the Emissions(kt) of Guinea-Bissau in 2005 to that in 2010?
Ensure brevity in your answer.  0.89. What is the ratio of the Emissions(kt) of Moldova in 2005 to that in 2010?
Ensure brevity in your answer.  0.99. What is the ratio of the Emissions(kt) of Cayman Islands in 2006 to that in 2007?
Give a very brief answer. 0.83. What is the ratio of the Emissions(kt) of Guinea in 2006 to that in 2007?
Your response must be concise. 0.98. What is the ratio of the Emissions(kt) of Guinea-Bissau in 2006 to that in 2007?
Offer a terse response. 0.94. What is the ratio of the Emissions(kt) in Moldova in 2006 to that in 2007?
Provide a short and direct response. 1.07. What is the ratio of the Emissions(kt) of Cayman Islands in 2006 to that in 2008?
Provide a succinct answer. 0.81. What is the ratio of the Emissions(kt) of Guinea in 2006 to that in 2008?
Your response must be concise. 0.59. What is the ratio of the Emissions(kt) of Guinea-Bissau in 2006 to that in 2008?
Your response must be concise. 0.95. What is the ratio of the Emissions(kt) of Moldova in 2006 to that in 2008?
Offer a terse response. 1.05. What is the ratio of the Emissions(kt) in Cayman Islands in 2006 to that in 2009?
Provide a short and direct response. 0.86. What is the ratio of the Emissions(kt) of Guinea in 2006 to that in 2009?
Make the answer very short. 0.56. What is the ratio of the Emissions(kt) of Guinea-Bissau in 2006 to that in 2009?
Your response must be concise. 0.92. What is the ratio of the Emissions(kt) of Moldova in 2006 to that in 2009?
Give a very brief answer. 1.1. What is the ratio of the Emissions(kt) in Cayman Islands in 2006 to that in 2010?
Keep it short and to the point. 0.86. What is the ratio of the Emissions(kt) of Guinea in 2006 to that in 2010?
Your answer should be very brief. 0.47. What is the ratio of the Emissions(kt) in Guinea-Bissau in 2006 to that in 2010?
Offer a terse response. 0.91. What is the ratio of the Emissions(kt) of Moldova in 2006 to that in 2010?
Offer a terse response. 1.01. What is the ratio of the Emissions(kt) in Cayman Islands in 2007 to that in 2008?
Provide a short and direct response. 0.98. What is the ratio of the Emissions(kt) of Guinea in 2007 to that in 2008?
Offer a very short reply. 0.61. What is the ratio of the Emissions(kt) in Guinea-Bissau in 2007 to that in 2008?
Your response must be concise. 1.02. What is the ratio of the Emissions(kt) in Moldova in 2007 to that in 2008?
Provide a short and direct response. 0.98. What is the ratio of the Emissions(kt) of Cayman Islands in 2007 to that in 2009?
Make the answer very short. 1.04. What is the ratio of the Emissions(kt) in Guinea in 2007 to that in 2009?
Keep it short and to the point. 0.57. What is the ratio of the Emissions(kt) in Guinea-Bissau in 2007 to that in 2009?
Your answer should be very brief. 0.98. What is the ratio of the Emissions(kt) in Moldova in 2007 to that in 2009?
Give a very brief answer. 1.03. What is the ratio of the Emissions(kt) of Cayman Islands in 2007 to that in 2010?
Provide a short and direct response. 1.03. What is the ratio of the Emissions(kt) of Guinea in 2007 to that in 2010?
Your response must be concise. 0.49. What is the ratio of the Emissions(kt) of Guinea-Bissau in 2007 to that in 2010?
Offer a terse response. 0.97. What is the ratio of the Emissions(kt) in Moldova in 2007 to that in 2010?
Offer a terse response. 0.95. What is the ratio of the Emissions(kt) of Cayman Islands in 2008 to that in 2009?
Your response must be concise. 1.06. What is the ratio of the Emissions(kt) of Guinea in 2008 to that in 2009?
Offer a very short reply. 0.95. What is the ratio of the Emissions(kt) in Guinea-Bissau in 2008 to that in 2009?
Give a very brief answer. 0.97. What is the ratio of the Emissions(kt) in Moldova in 2008 to that in 2009?
Ensure brevity in your answer.  1.05. What is the ratio of the Emissions(kt) of Cayman Islands in 2008 to that in 2010?
Offer a terse response. 1.05. What is the ratio of the Emissions(kt) of Guinea in 2008 to that in 2010?
Provide a short and direct response. 0.8. What is the ratio of the Emissions(kt) of Guinea-Bissau in 2008 to that in 2010?
Provide a succinct answer. 0.95. What is the ratio of the Emissions(kt) of Moldova in 2008 to that in 2010?
Your response must be concise. 0.97. What is the ratio of the Emissions(kt) in Cayman Islands in 2009 to that in 2010?
Provide a succinct answer. 0.99. What is the ratio of the Emissions(kt) in Guinea in 2009 to that in 2010?
Your answer should be very brief. 0.85. What is the ratio of the Emissions(kt) in Guinea-Bissau in 2009 to that in 2010?
Your response must be concise. 0.98. What is the ratio of the Emissions(kt) of Moldova in 2009 to that in 2010?
Give a very brief answer. 0.92. What is the difference between the highest and the second highest Emissions(kt) of Cayman Islands?
Ensure brevity in your answer.  11. What is the difference between the highest and the second highest Emissions(kt) in Guinea?
Your response must be concise. 377.7. What is the difference between the highest and the second highest Emissions(kt) in Guinea-Bissau?
Your response must be concise. 3.67. What is the difference between the highest and the second highest Emissions(kt) in Moldova?
Offer a very short reply. 58.67. What is the difference between the highest and the lowest Emissions(kt) of Cayman Islands?
Ensure brevity in your answer.  132.01. What is the difference between the highest and the lowest Emissions(kt) of Guinea?
Your answer should be very brief. 1305.45. What is the difference between the highest and the lowest Emissions(kt) in Guinea-Bissau?
Ensure brevity in your answer.  44. What is the difference between the highest and the lowest Emissions(kt) of Moldova?
Make the answer very short. 704.06. 